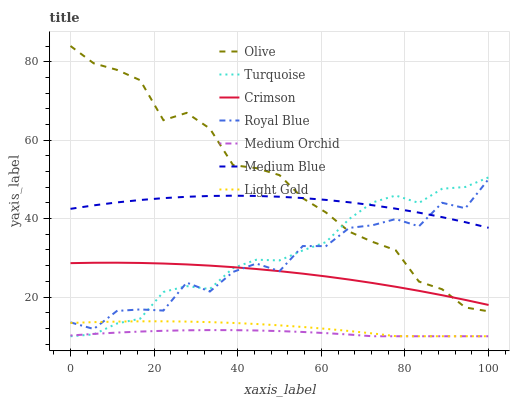Does Medium Orchid have the minimum area under the curve?
Answer yes or no. Yes. Does Olive have the maximum area under the curve?
Answer yes or no. Yes. Does Royal Blue have the minimum area under the curve?
Answer yes or no. No. Does Royal Blue have the maximum area under the curve?
Answer yes or no. No. Is Medium Orchid the smoothest?
Answer yes or no. Yes. Is Royal Blue the roughest?
Answer yes or no. Yes. Is Royal Blue the smoothest?
Answer yes or no. No. Is Medium Orchid the roughest?
Answer yes or no. No. Does Turquoise have the lowest value?
Answer yes or no. Yes. Does Royal Blue have the lowest value?
Answer yes or no. No. Does Olive have the highest value?
Answer yes or no. Yes. Does Royal Blue have the highest value?
Answer yes or no. No. Is Medium Orchid less than Crimson?
Answer yes or no. Yes. Is Medium Blue greater than Medium Orchid?
Answer yes or no. Yes. Does Olive intersect Crimson?
Answer yes or no. Yes. Is Olive less than Crimson?
Answer yes or no. No. Is Olive greater than Crimson?
Answer yes or no. No. Does Medium Orchid intersect Crimson?
Answer yes or no. No. 